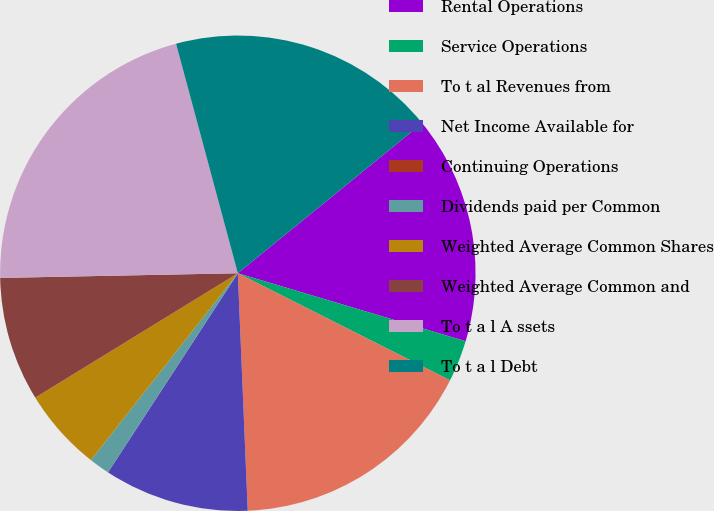Convert chart to OTSL. <chart><loc_0><loc_0><loc_500><loc_500><pie_chart><fcel>Rental Operations<fcel>Service Operations<fcel>To t al Revenues from<fcel>Net Income Available for<fcel>Continuing Operations<fcel>Dividends paid per Common<fcel>Weighted Average Common Shares<fcel>Weighted Average Common and<fcel>To t a l A ssets<fcel>To t a l Debt<nl><fcel>15.49%<fcel>2.82%<fcel>16.9%<fcel>9.86%<fcel>0.0%<fcel>1.41%<fcel>5.63%<fcel>8.45%<fcel>21.13%<fcel>18.31%<nl></chart> 